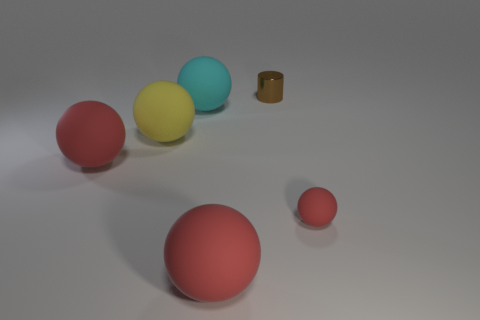What is the small brown thing made of?
Your response must be concise. Metal. What is the shape of the small object that is behind the large red thing behind the large object that is right of the cyan rubber sphere?
Your answer should be compact. Cylinder. How many other objects are there of the same material as the cylinder?
Offer a terse response. 0. Is the big ball on the right side of the cyan ball made of the same material as the tiny object that is behind the tiny red ball?
Your response must be concise. No. How many spheres are both in front of the cyan matte thing and on the left side of the tiny red rubber sphere?
Provide a succinct answer. 3. Is there a big red object that has the same shape as the cyan rubber object?
Your answer should be very brief. Yes. What is the shape of the cyan thing that is the same size as the yellow matte sphere?
Provide a succinct answer. Sphere. Is the number of things on the right side of the brown metallic cylinder the same as the number of yellow spheres left of the big cyan rubber sphere?
Your response must be concise. Yes. What is the size of the red matte sphere to the left of the rubber object behind the yellow rubber thing?
Provide a succinct answer. Large. Are there any other brown things that have the same size as the brown metal thing?
Provide a succinct answer. No. 